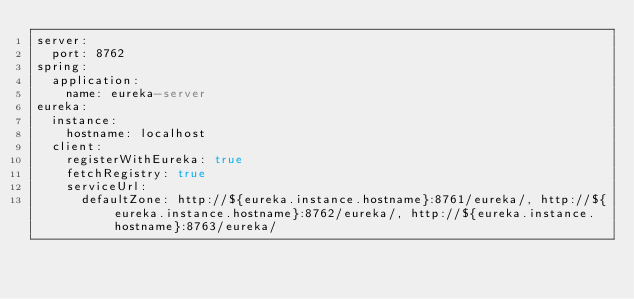Convert code to text. <code><loc_0><loc_0><loc_500><loc_500><_YAML_>server:
  port: 8762
spring:
  application:
    name: eureka-server
eureka:
  instance:
    hostname: localhost
  client:
    registerWithEureka: true
    fetchRegistry: true
    serviceUrl:
      defaultZone: http://${eureka.instance.hostname}:8761/eureka/, http://${eureka.instance.hostname}:8762/eureka/, http://${eureka.instance.hostname}:8763/eureka/</code> 